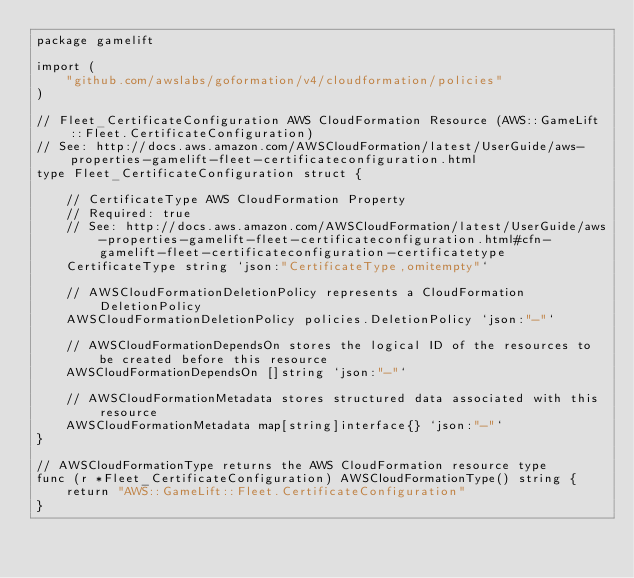<code> <loc_0><loc_0><loc_500><loc_500><_Go_>package gamelift

import (
	"github.com/awslabs/goformation/v4/cloudformation/policies"
)

// Fleet_CertificateConfiguration AWS CloudFormation Resource (AWS::GameLift::Fleet.CertificateConfiguration)
// See: http://docs.aws.amazon.com/AWSCloudFormation/latest/UserGuide/aws-properties-gamelift-fleet-certificateconfiguration.html
type Fleet_CertificateConfiguration struct {

	// CertificateType AWS CloudFormation Property
	// Required: true
	// See: http://docs.aws.amazon.com/AWSCloudFormation/latest/UserGuide/aws-properties-gamelift-fleet-certificateconfiguration.html#cfn-gamelift-fleet-certificateconfiguration-certificatetype
	CertificateType string `json:"CertificateType,omitempty"`

	// AWSCloudFormationDeletionPolicy represents a CloudFormation DeletionPolicy
	AWSCloudFormationDeletionPolicy policies.DeletionPolicy `json:"-"`

	// AWSCloudFormationDependsOn stores the logical ID of the resources to be created before this resource
	AWSCloudFormationDependsOn []string `json:"-"`

	// AWSCloudFormationMetadata stores structured data associated with this resource
	AWSCloudFormationMetadata map[string]interface{} `json:"-"`
}

// AWSCloudFormationType returns the AWS CloudFormation resource type
func (r *Fleet_CertificateConfiguration) AWSCloudFormationType() string {
	return "AWS::GameLift::Fleet.CertificateConfiguration"
}
</code> 